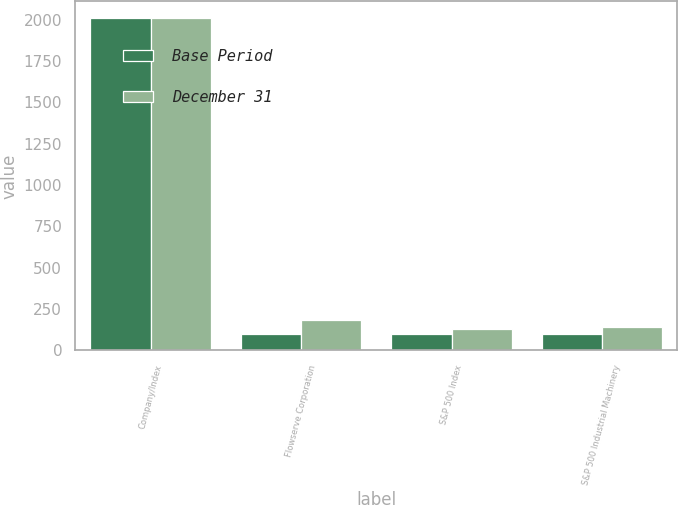<chart> <loc_0><loc_0><loc_500><loc_500><stacked_bar_chart><ecel><fcel>Company/Index<fcel>Flowserve Corporation<fcel>S&P 500 Index<fcel>S&P 500 Industrial Machinery<nl><fcel>Base Period<fcel>2008<fcel>100<fcel>100<fcel>100<nl><fcel>December 31<fcel>2009<fcel>186.09<fcel>126.45<fcel>139.72<nl></chart> 